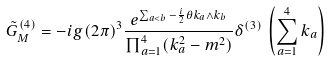Convert formula to latex. <formula><loc_0><loc_0><loc_500><loc_500>\tilde { G } _ { M } ^ { ( 4 ) } = - i g ( 2 \pi ) ^ { 3 } \frac { e ^ { \sum _ { a < b } - \frac { i } { 2 } \theta k _ { a } \wedge k _ { b } } } { \prod _ { a = 1 } ^ { 4 } ( k _ { a } ^ { 2 } - m ^ { 2 } ) } \delta ^ { ( 3 ) } \, \left ( \sum _ { a = 1 } ^ { 4 } k _ { a } \right )</formula> 